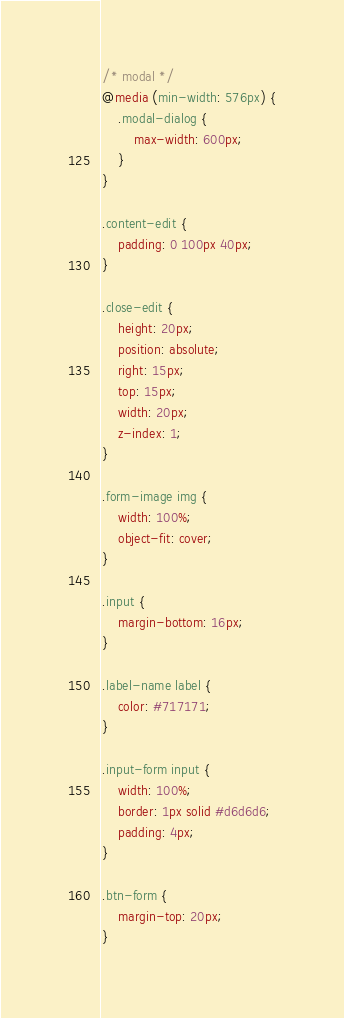<code> <loc_0><loc_0><loc_500><loc_500><_CSS_>/* modal */
@media (min-width: 576px) {
    .modal-dialog {
        max-width: 600px;
    }
}

.content-edit {
    padding: 0 100px 40px;
}

.close-edit {
    height: 20px;
    position: absolute;
    right: 15px;
    top: 15px;
    width: 20px;
    z-index: 1;
}

.form-image img {
    width: 100%;
    object-fit: cover;
}

.input {
    margin-bottom: 16px;
}

.label-name label {
    color: #717171;
}

.input-form input {
    width: 100%;
    border: 1px solid #d6d6d6;
    padding: 4px;
}

.btn-form {
    margin-top: 20px;
}
</code> 